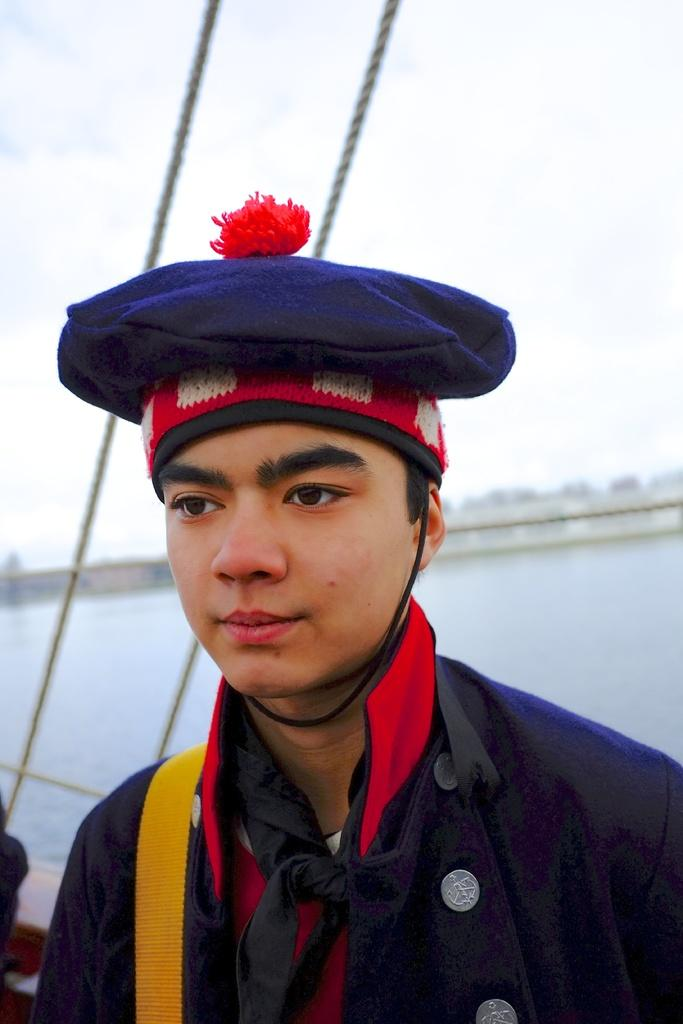What is the main subject of the image? The main subject of the image is a boat. What are the two threads in the image used for? The purpose of the two threads in the image is not specified, but they could be used for tying or securing the boat. What body of water is the boat in? The boat is in a river in the image. What type of vegetation is present in the image? There are trees in the image. Can you describe the person in the image? There is a person with a blue cap in the image. What is visible at the top of the image? The sky is visible at the top of the image. How many frogs are sitting on the board in the image? There are no frogs or boards present in the image. 